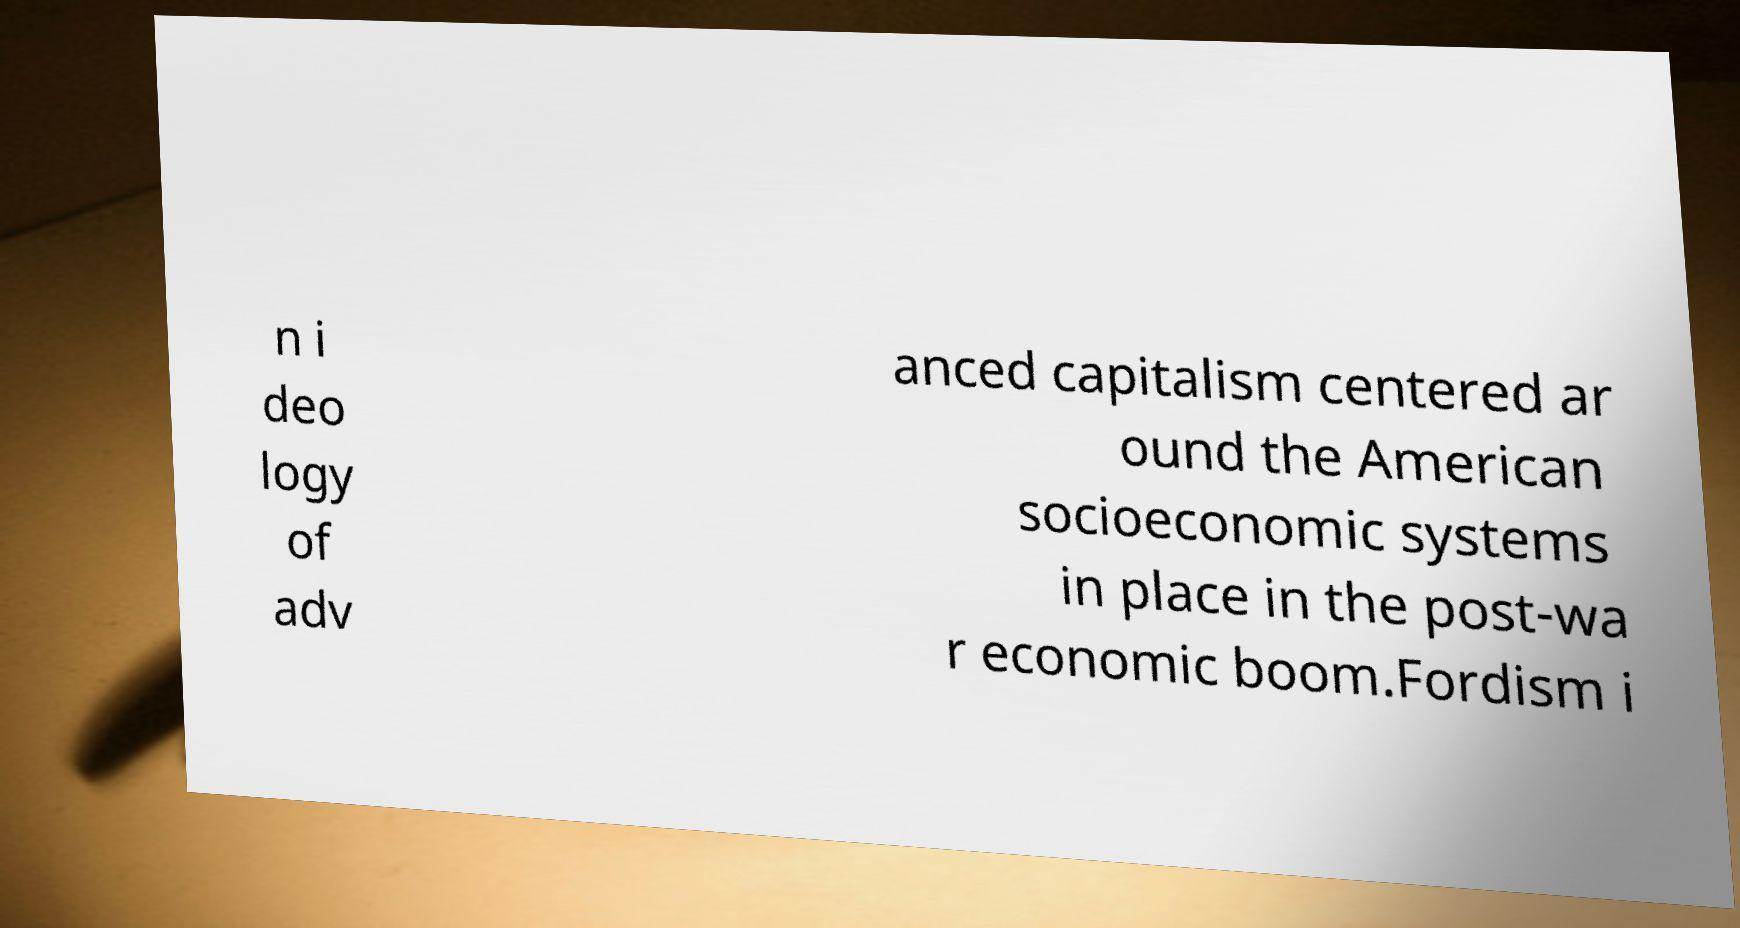I need the written content from this picture converted into text. Can you do that? n i deo logy of adv anced capitalism centered ar ound the American socioeconomic systems in place in the post-wa r economic boom.Fordism i 